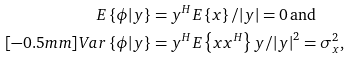<formula> <loc_0><loc_0><loc_500><loc_500>E \left \{ { { \phi } | { y } } \right \} & = { { y } ^ { H } } E \left \{ { x } \right \} / { { \left | { y } \right | } } = 0 \, \text {and} \\ [ - 0 . 5 m m ] V a r \left \{ { { \phi } | { y } } \right \} & = { { { y } ^ { H } E \left \{ { { x } { { x } ^ { H } } } \right \} { y } } } / { { { { \left | { y } \right | } ^ { 2 } } } } = \sigma _ { x } ^ { 2 } ,</formula> 